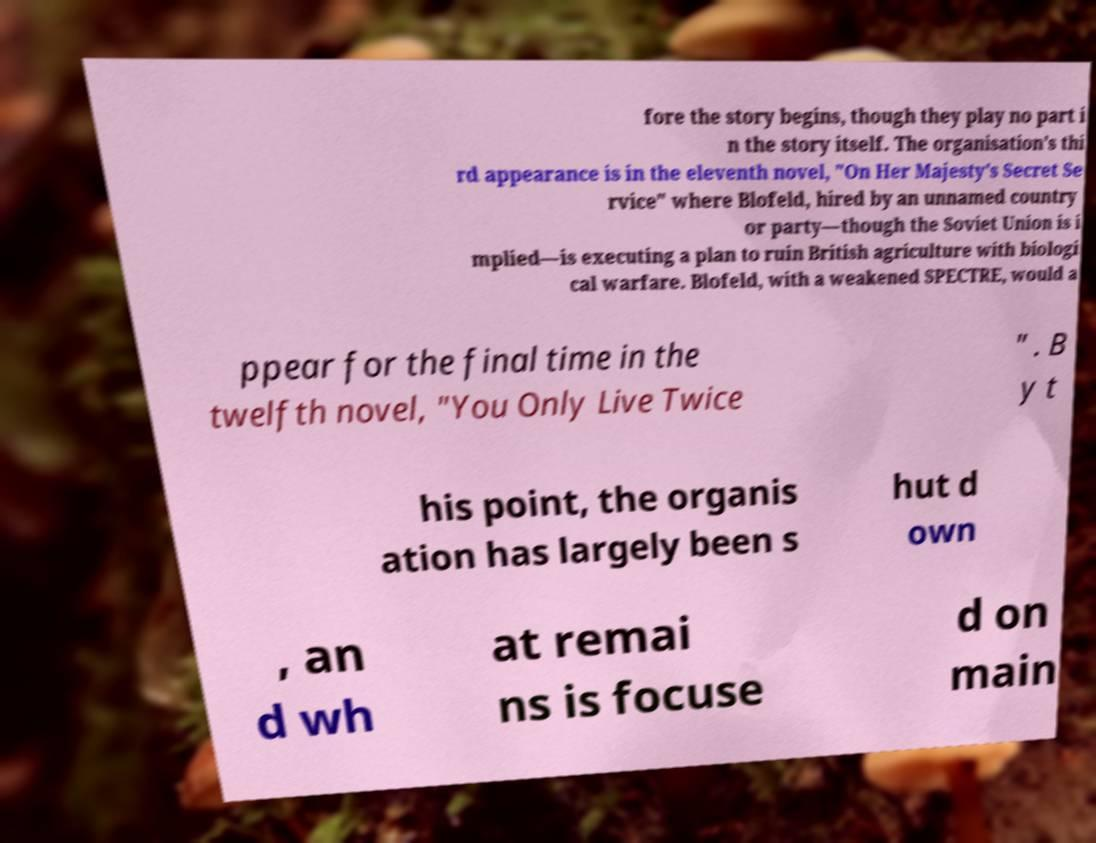What messages or text are displayed in this image? I need them in a readable, typed format. fore the story begins, though they play no part i n the story itself. The organisation's thi rd appearance is in the eleventh novel, "On Her Majesty's Secret Se rvice" where Blofeld, hired by an unnamed country or party—though the Soviet Union is i mplied—is executing a plan to ruin British agriculture with biologi cal warfare. Blofeld, with a weakened SPECTRE, would a ppear for the final time in the twelfth novel, "You Only Live Twice " . B y t his point, the organis ation has largely been s hut d own , an d wh at remai ns is focuse d on main 